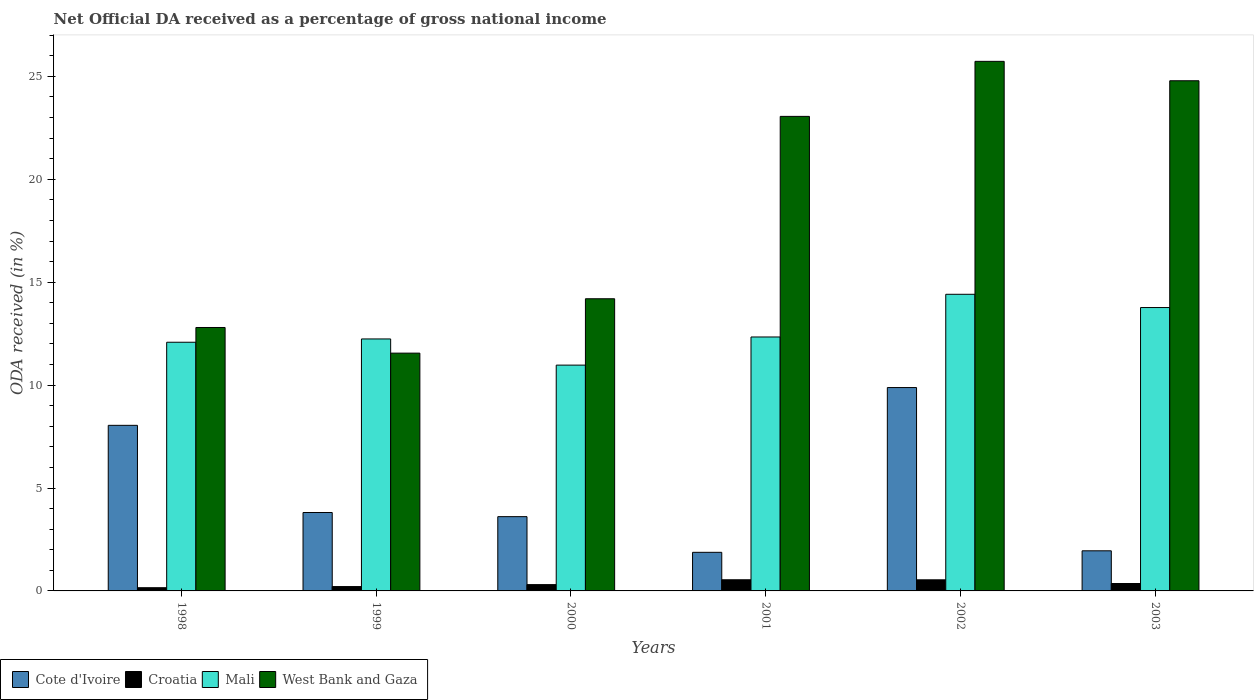How many different coloured bars are there?
Your answer should be compact. 4. How many groups of bars are there?
Provide a succinct answer. 6. Are the number of bars per tick equal to the number of legend labels?
Your response must be concise. Yes. What is the label of the 3rd group of bars from the left?
Your answer should be very brief. 2000. In how many cases, is the number of bars for a given year not equal to the number of legend labels?
Make the answer very short. 0. What is the net official DA received in Cote d'Ivoire in 1998?
Provide a succinct answer. 8.05. Across all years, what is the maximum net official DA received in Cote d'Ivoire?
Offer a very short reply. 9.88. Across all years, what is the minimum net official DA received in Cote d'Ivoire?
Your answer should be very brief. 1.88. In which year was the net official DA received in Mali maximum?
Offer a very short reply. 2002. In which year was the net official DA received in Mali minimum?
Offer a terse response. 2000. What is the total net official DA received in West Bank and Gaza in the graph?
Keep it short and to the point. 112.11. What is the difference between the net official DA received in Croatia in 1999 and that in 2001?
Your answer should be very brief. -0.33. What is the difference between the net official DA received in Cote d'Ivoire in 2000 and the net official DA received in Croatia in 2002?
Provide a succinct answer. 3.07. What is the average net official DA received in Croatia per year?
Ensure brevity in your answer.  0.35. In the year 1999, what is the difference between the net official DA received in Mali and net official DA received in Croatia?
Your answer should be compact. 12.03. In how many years, is the net official DA received in Cote d'Ivoire greater than 12 %?
Your answer should be very brief. 0. What is the ratio of the net official DA received in West Bank and Gaza in 2000 to that in 2001?
Offer a terse response. 0.62. Is the difference between the net official DA received in Mali in 2002 and 2003 greater than the difference between the net official DA received in Croatia in 2002 and 2003?
Offer a very short reply. Yes. What is the difference between the highest and the second highest net official DA received in West Bank and Gaza?
Your answer should be compact. 0.94. What is the difference between the highest and the lowest net official DA received in Croatia?
Ensure brevity in your answer.  0.39. Is it the case that in every year, the sum of the net official DA received in Cote d'Ivoire and net official DA received in Mali is greater than the sum of net official DA received in Croatia and net official DA received in West Bank and Gaza?
Ensure brevity in your answer.  Yes. What does the 1st bar from the left in 1999 represents?
Your answer should be compact. Cote d'Ivoire. What does the 4th bar from the right in 2002 represents?
Your response must be concise. Cote d'Ivoire. Is it the case that in every year, the sum of the net official DA received in West Bank and Gaza and net official DA received in Cote d'Ivoire is greater than the net official DA received in Mali?
Offer a very short reply. Yes. Are all the bars in the graph horizontal?
Provide a short and direct response. No. Where does the legend appear in the graph?
Offer a very short reply. Bottom left. How are the legend labels stacked?
Your answer should be very brief. Horizontal. What is the title of the graph?
Give a very brief answer. Net Official DA received as a percentage of gross national income. Does "China" appear as one of the legend labels in the graph?
Give a very brief answer. No. What is the label or title of the X-axis?
Your answer should be compact. Years. What is the label or title of the Y-axis?
Give a very brief answer. ODA received (in %). What is the ODA received (in %) of Cote d'Ivoire in 1998?
Ensure brevity in your answer.  8.05. What is the ODA received (in %) of Croatia in 1998?
Give a very brief answer. 0.16. What is the ODA received (in %) in Mali in 1998?
Make the answer very short. 12.08. What is the ODA received (in %) in West Bank and Gaza in 1998?
Keep it short and to the point. 12.8. What is the ODA received (in %) in Cote d'Ivoire in 1999?
Your answer should be very brief. 3.81. What is the ODA received (in %) in Croatia in 1999?
Your response must be concise. 0.21. What is the ODA received (in %) in Mali in 1999?
Offer a terse response. 12.24. What is the ODA received (in %) in West Bank and Gaza in 1999?
Provide a short and direct response. 11.55. What is the ODA received (in %) of Cote d'Ivoire in 2000?
Keep it short and to the point. 3.61. What is the ODA received (in %) in Croatia in 2000?
Provide a succinct answer. 0.31. What is the ODA received (in %) of Mali in 2000?
Keep it short and to the point. 10.97. What is the ODA received (in %) in West Bank and Gaza in 2000?
Offer a terse response. 14.19. What is the ODA received (in %) in Cote d'Ivoire in 2001?
Your answer should be very brief. 1.88. What is the ODA received (in %) in Croatia in 2001?
Keep it short and to the point. 0.54. What is the ODA received (in %) in Mali in 2001?
Make the answer very short. 12.34. What is the ODA received (in %) of West Bank and Gaza in 2001?
Offer a terse response. 23.05. What is the ODA received (in %) in Cote d'Ivoire in 2002?
Make the answer very short. 9.88. What is the ODA received (in %) of Croatia in 2002?
Provide a succinct answer. 0.54. What is the ODA received (in %) in Mali in 2002?
Make the answer very short. 14.41. What is the ODA received (in %) in West Bank and Gaza in 2002?
Your answer should be very brief. 25.73. What is the ODA received (in %) in Cote d'Ivoire in 2003?
Offer a very short reply. 1.95. What is the ODA received (in %) in Croatia in 2003?
Your answer should be very brief. 0.36. What is the ODA received (in %) in Mali in 2003?
Offer a very short reply. 13.77. What is the ODA received (in %) of West Bank and Gaza in 2003?
Offer a very short reply. 24.79. Across all years, what is the maximum ODA received (in %) of Cote d'Ivoire?
Make the answer very short. 9.88. Across all years, what is the maximum ODA received (in %) of Croatia?
Keep it short and to the point. 0.54. Across all years, what is the maximum ODA received (in %) in Mali?
Your answer should be compact. 14.41. Across all years, what is the maximum ODA received (in %) in West Bank and Gaza?
Provide a short and direct response. 25.73. Across all years, what is the minimum ODA received (in %) in Cote d'Ivoire?
Your answer should be compact. 1.88. Across all years, what is the minimum ODA received (in %) of Croatia?
Offer a terse response. 0.16. Across all years, what is the minimum ODA received (in %) in Mali?
Ensure brevity in your answer.  10.97. Across all years, what is the minimum ODA received (in %) of West Bank and Gaza?
Your answer should be compact. 11.55. What is the total ODA received (in %) of Cote d'Ivoire in the graph?
Make the answer very short. 29.17. What is the total ODA received (in %) of Croatia in the graph?
Offer a terse response. 2.11. What is the total ODA received (in %) of Mali in the graph?
Your answer should be compact. 75.81. What is the total ODA received (in %) in West Bank and Gaza in the graph?
Your answer should be very brief. 112.11. What is the difference between the ODA received (in %) in Cote d'Ivoire in 1998 and that in 1999?
Your answer should be compact. 4.24. What is the difference between the ODA received (in %) in Croatia in 1998 and that in 1999?
Your response must be concise. -0.06. What is the difference between the ODA received (in %) of Mali in 1998 and that in 1999?
Your answer should be very brief. -0.16. What is the difference between the ODA received (in %) of West Bank and Gaza in 1998 and that in 1999?
Provide a succinct answer. 1.25. What is the difference between the ODA received (in %) of Cote d'Ivoire in 1998 and that in 2000?
Ensure brevity in your answer.  4.44. What is the difference between the ODA received (in %) of Croatia in 1998 and that in 2000?
Make the answer very short. -0.15. What is the difference between the ODA received (in %) of Mali in 1998 and that in 2000?
Your answer should be compact. 1.11. What is the difference between the ODA received (in %) of West Bank and Gaza in 1998 and that in 2000?
Offer a very short reply. -1.4. What is the difference between the ODA received (in %) of Cote d'Ivoire in 1998 and that in 2001?
Offer a terse response. 6.17. What is the difference between the ODA received (in %) of Croatia in 1998 and that in 2001?
Give a very brief answer. -0.39. What is the difference between the ODA received (in %) in Mali in 1998 and that in 2001?
Provide a succinct answer. -0.26. What is the difference between the ODA received (in %) of West Bank and Gaza in 1998 and that in 2001?
Provide a succinct answer. -10.26. What is the difference between the ODA received (in %) in Cote d'Ivoire in 1998 and that in 2002?
Your answer should be very brief. -1.84. What is the difference between the ODA received (in %) in Croatia in 1998 and that in 2002?
Ensure brevity in your answer.  -0.38. What is the difference between the ODA received (in %) in Mali in 1998 and that in 2002?
Offer a very short reply. -2.33. What is the difference between the ODA received (in %) of West Bank and Gaza in 1998 and that in 2002?
Your answer should be compact. -12.93. What is the difference between the ODA received (in %) in Cote d'Ivoire in 1998 and that in 2003?
Ensure brevity in your answer.  6.1. What is the difference between the ODA received (in %) of Croatia in 1998 and that in 2003?
Your response must be concise. -0.2. What is the difference between the ODA received (in %) of Mali in 1998 and that in 2003?
Offer a terse response. -1.69. What is the difference between the ODA received (in %) of West Bank and Gaza in 1998 and that in 2003?
Make the answer very short. -11.99. What is the difference between the ODA received (in %) in Cote d'Ivoire in 1999 and that in 2000?
Offer a terse response. 0.2. What is the difference between the ODA received (in %) in Croatia in 1999 and that in 2000?
Provide a short and direct response. -0.09. What is the difference between the ODA received (in %) of Mali in 1999 and that in 2000?
Provide a succinct answer. 1.27. What is the difference between the ODA received (in %) in West Bank and Gaza in 1999 and that in 2000?
Give a very brief answer. -2.64. What is the difference between the ODA received (in %) in Cote d'Ivoire in 1999 and that in 2001?
Your answer should be compact. 1.93. What is the difference between the ODA received (in %) of Croatia in 1999 and that in 2001?
Provide a short and direct response. -0.33. What is the difference between the ODA received (in %) of Mali in 1999 and that in 2001?
Provide a succinct answer. -0.1. What is the difference between the ODA received (in %) in West Bank and Gaza in 1999 and that in 2001?
Ensure brevity in your answer.  -11.5. What is the difference between the ODA received (in %) of Cote d'Ivoire in 1999 and that in 2002?
Offer a terse response. -6.07. What is the difference between the ODA received (in %) of Croatia in 1999 and that in 2002?
Your answer should be compact. -0.33. What is the difference between the ODA received (in %) in Mali in 1999 and that in 2002?
Give a very brief answer. -2.17. What is the difference between the ODA received (in %) of West Bank and Gaza in 1999 and that in 2002?
Keep it short and to the point. -14.18. What is the difference between the ODA received (in %) of Cote d'Ivoire in 1999 and that in 2003?
Keep it short and to the point. 1.86. What is the difference between the ODA received (in %) in Croatia in 1999 and that in 2003?
Give a very brief answer. -0.15. What is the difference between the ODA received (in %) of Mali in 1999 and that in 2003?
Provide a short and direct response. -1.53. What is the difference between the ODA received (in %) in West Bank and Gaza in 1999 and that in 2003?
Your answer should be compact. -13.23. What is the difference between the ODA received (in %) in Cote d'Ivoire in 2000 and that in 2001?
Make the answer very short. 1.73. What is the difference between the ODA received (in %) of Croatia in 2000 and that in 2001?
Make the answer very short. -0.23. What is the difference between the ODA received (in %) of Mali in 2000 and that in 2001?
Give a very brief answer. -1.37. What is the difference between the ODA received (in %) of West Bank and Gaza in 2000 and that in 2001?
Offer a very short reply. -8.86. What is the difference between the ODA received (in %) of Cote d'Ivoire in 2000 and that in 2002?
Provide a short and direct response. -6.27. What is the difference between the ODA received (in %) in Croatia in 2000 and that in 2002?
Your answer should be compact. -0.23. What is the difference between the ODA received (in %) of Mali in 2000 and that in 2002?
Offer a terse response. -3.44. What is the difference between the ODA received (in %) in West Bank and Gaza in 2000 and that in 2002?
Provide a succinct answer. -11.53. What is the difference between the ODA received (in %) of Cote d'Ivoire in 2000 and that in 2003?
Make the answer very short. 1.66. What is the difference between the ODA received (in %) of Croatia in 2000 and that in 2003?
Your answer should be very brief. -0.05. What is the difference between the ODA received (in %) in Mali in 2000 and that in 2003?
Offer a very short reply. -2.8. What is the difference between the ODA received (in %) of West Bank and Gaza in 2000 and that in 2003?
Your answer should be very brief. -10.59. What is the difference between the ODA received (in %) in Cote d'Ivoire in 2001 and that in 2002?
Provide a succinct answer. -8. What is the difference between the ODA received (in %) of Croatia in 2001 and that in 2002?
Your response must be concise. 0. What is the difference between the ODA received (in %) in Mali in 2001 and that in 2002?
Your response must be concise. -2.07. What is the difference between the ODA received (in %) of West Bank and Gaza in 2001 and that in 2002?
Offer a very short reply. -2.67. What is the difference between the ODA received (in %) in Cote d'Ivoire in 2001 and that in 2003?
Offer a terse response. -0.07. What is the difference between the ODA received (in %) of Croatia in 2001 and that in 2003?
Your response must be concise. 0.18. What is the difference between the ODA received (in %) in Mali in 2001 and that in 2003?
Keep it short and to the point. -1.43. What is the difference between the ODA received (in %) in West Bank and Gaza in 2001 and that in 2003?
Your answer should be compact. -1.73. What is the difference between the ODA received (in %) in Cote d'Ivoire in 2002 and that in 2003?
Your answer should be very brief. 7.93. What is the difference between the ODA received (in %) in Croatia in 2002 and that in 2003?
Keep it short and to the point. 0.18. What is the difference between the ODA received (in %) of Mali in 2002 and that in 2003?
Offer a terse response. 0.64. What is the difference between the ODA received (in %) of West Bank and Gaza in 2002 and that in 2003?
Your answer should be compact. 0.94. What is the difference between the ODA received (in %) in Cote d'Ivoire in 1998 and the ODA received (in %) in Croatia in 1999?
Keep it short and to the point. 7.83. What is the difference between the ODA received (in %) in Cote d'Ivoire in 1998 and the ODA received (in %) in Mali in 1999?
Provide a succinct answer. -4.2. What is the difference between the ODA received (in %) of Cote d'Ivoire in 1998 and the ODA received (in %) of West Bank and Gaza in 1999?
Your response must be concise. -3.51. What is the difference between the ODA received (in %) of Croatia in 1998 and the ODA received (in %) of Mali in 1999?
Make the answer very short. -12.09. What is the difference between the ODA received (in %) of Croatia in 1998 and the ODA received (in %) of West Bank and Gaza in 1999?
Provide a succinct answer. -11.4. What is the difference between the ODA received (in %) in Mali in 1998 and the ODA received (in %) in West Bank and Gaza in 1999?
Ensure brevity in your answer.  0.53. What is the difference between the ODA received (in %) of Cote d'Ivoire in 1998 and the ODA received (in %) of Croatia in 2000?
Offer a terse response. 7.74. What is the difference between the ODA received (in %) of Cote d'Ivoire in 1998 and the ODA received (in %) of Mali in 2000?
Offer a very short reply. -2.92. What is the difference between the ODA received (in %) in Cote d'Ivoire in 1998 and the ODA received (in %) in West Bank and Gaza in 2000?
Your answer should be compact. -6.15. What is the difference between the ODA received (in %) in Croatia in 1998 and the ODA received (in %) in Mali in 2000?
Make the answer very short. -10.81. What is the difference between the ODA received (in %) in Croatia in 1998 and the ODA received (in %) in West Bank and Gaza in 2000?
Provide a succinct answer. -14.04. What is the difference between the ODA received (in %) in Mali in 1998 and the ODA received (in %) in West Bank and Gaza in 2000?
Keep it short and to the point. -2.11. What is the difference between the ODA received (in %) of Cote d'Ivoire in 1998 and the ODA received (in %) of Croatia in 2001?
Provide a short and direct response. 7.5. What is the difference between the ODA received (in %) in Cote d'Ivoire in 1998 and the ODA received (in %) in Mali in 2001?
Your response must be concise. -4.29. What is the difference between the ODA received (in %) in Cote d'Ivoire in 1998 and the ODA received (in %) in West Bank and Gaza in 2001?
Your answer should be compact. -15.01. What is the difference between the ODA received (in %) in Croatia in 1998 and the ODA received (in %) in Mali in 2001?
Your answer should be very brief. -12.18. What is the difference between the ODA received (in %) in Croatia in 1998 and the ODA received (in %) in West Bank and Gaza in 2001?
Your response must be concise. -22.9. What is the difference between the ODA received (in %) of Mali in 1998 and the ODA received (in %) of West Bank and Gaza in 2001?
Make the answer very short. -10.97. What is the difference between the ODA received (in %) of Cote d'Ivoire in 1998 and the ODA received (in %) of Croatia in 2002?
Your answer should be compact. 7.51. What is the difference between the ODA received (in %) in Cote d'Ivoire in 1998 and the ODA received (in %) in Mali in 2002?
Your response must be concise. -6.37. What is the difference between the ODA received (in %) in Cote d'Ivoire in 1998 and the ODA received (in %) in West Bank and Gaza in 2002?
Provide a succinct answer. -17.68. What is the difference between the ODA received (in %) in Croatia in 1998 and the ODA received (in %) in Mali in 2002?
Your response must be concise. -14.26. What is the difference between the ODA received (in %) of Croatia in 1998 and the ODA received (in %) of West Bank and Gaza in 2002?
Give a very brief answer. -25.57. What is the difference between the ODA received (in %) in Mali in 1998 and the ODA received (in %) in West Bank and Gaza in 2002?
Keep it short and to the point. -13.65. What is the difference between the ODA received (in %) in Cote d'Ivoire in 1998 and the ODA received (in %) in Croatia in 2003?
Your answer should be compact. 7.69. What is the difference between the ODA received (in %) in Cote d'Ivoire in 1998 and the ODA received (in %) in Mali in 2003?
Your answer should be very brief. -5.72. What is the difference between the ODA received (in %) of Cote d'Ivoire in 1998 and the ODA received (in %) of West Bank and Gaza in 2003?
Keep it short and to the point. -16.74. What is the difference between the ODA received (in %) of Croatia in 1998 and the ODA received (in %) of Mali in 2003?
Your answer should be very brief. -13.61. What is the difference between the ODA received (in %) of Croatia in 1998 and the ODA received (in %) of West Bank and Gaza in 2003?
Ensure brevity in your answer.  -24.63. What is the difference between the ODA received (in %) of Mali in 1998 and the ODA received (in %) of West Bank and Gaza in 2003?
Keep it short and to the point. -12.7. What is the difference between the ODA received (in %) of Cote d'Ivoire in 1999 and the ODA received (in %) of Croatia in 2000?
Offer a very short reply. 3.5. What is the difference between the ODA received (in %) in Cote d'Ivoire in 1999 and the ODA received (in %) in Mali in 2000?
Offer a terse response. -7.16. What is the difference between the ODA received (in %) in Cote d'Ivoire in 1999 and the ODA received (in %) in West Bank and Gaza in 2000?
Give a very brief answer. -10.38. What is the difference between the ODA received (in %) in Croatia in 1999 and the ODA received (in %) in Mali in 2000?
Your answer should be compact. -10.76. What is the difference between the ODA received (in %) of Croatia in 1999 and the ODA received (in %) of West Bank and Gaza in 2000?
Your answer should be very brief. -13.98. What is the difference between the ODA received (in %) in Mali in 1999 and the ODA received (in %) in West Bank and Gaza in 2000?
Your answer should be very brief. -1.95. What is the difference between the ODA received (in %) in Cote d'Ivoire in 1999 and the ODA received (in %) in Croatia in 2001?
Your response must be concise. 3.27. What is the difference between the ODA received (in %) in Cote d'Ivoire in 1999 and the ODA received (in %) in Mali in 2001?
Provide a short and direct response. -8.53. What is the difference between the ODA received (in %) of Cote d'Ivoire in 1999 and the ODA received (in %) of West Bank and Gaza in 2001?
Offer a very short reply. -19.24. What is the difference between the ODA received (in %) in Croatia in 1999 and the ODA received (in %) in Mali in 2001?
Keep it short and to the point. -12.13. What is the difference between the ODA received (in %) of Croatia in 1999 and the ODA received (in %) of West Bank and Gaza in 2001?
Ensure brevity in your answer.  -22.84. What is the difference between the ODA received (in %) of Mali in 1999 and the ODA received (in %) of West Bank and Gaza in 2001?
Your answer should be compact. -10.81. What is the difference between the ODA received (in %) in Cote d'Ivoire in 1999 and the ODA received (in %) in Croatia in 2002?
Make the answer very short. 3.27. What is the difference between the ODA received (in %) in Cote d'Ivoire in 1999 and the ODA received (in %) in Mali in 2002?
Keep it short and to the point. -10.6. What is the difference between the ODA received (in %) of Cote d'Ivoire in 1999 and the ODA received (in %) of West Bank and Gaza in 2002?
Your answer should be compact. -21.92. What is the difference between the ODA received (in %) of Croatia in 1999 and the ODA received (in %) of Mali in 2002?
Offer a terse response. -14.2. What is the difference between the ODA received (in %) in Croatia in 1999 and the ODA received (in %) in West Bank and Gaza in 2002?
Give a very brief answer. -25.52. What is the difference between the ODA received (in %) in Mali in 1999 and the ODA received (in %) in West Bank and Gaza in 2002?
Keep it short and to the point. -13.49. What is the difference between the ODA received (in %) in Cote d'Ivoire in 1999 and the ODA received (in %) in Croatia in 2003?
Your answer should be compact. 3.45. What is the difference between the ODA received (in %) in Cote d'Ivoire in 1999 and the ODA received (in %) in Mali in 2003?
Make the answer very short. -9.96. What is the difference between the ODA received (in %) in Cote d'Ivoire in 1999 and the ODA received (in %) in West Bank and Gaza in 2003?
Keep it short and to the point. -20.98. What is the difference between the ODA received (in %) in Croatia in 1999 and the ODA received (in %) in Mali in 2003?
Your answer should be compact. -13.56. What is the difference between the ODA received (in %) of Croatia in 1999 and the ODA received (in %) of West Bank and Gaza in 2003?
Keep it short and to the point. -24.57. What is the difference between the ODA received (in %) of Mali in 1999 and the ODA received (in %) of West Bank and Gaza in 2003?
Your response must be concise. -12.54. What is the difference between the ODA received (in %) of Cote d'Ivoire in 2000 and the ODA received (in %) of Croatia in 2001?
Provide a short and direct response. 3.07. What is the difference between the ODA received (in %) of Cote d'Ivoire in 2000 and the ODA received (in %) of Mali in 2001?
Offer a terse response. -8.73. What is the difference between the ODA received (in %) of Cote d'Ivoire in 2000 and the ODA received (in %) of West Bank and Gaza in 2001?
Provide a short and direct response. -19.45. What is the difference between the ODA received (in %) in Croatia in 2000 and the ODA received (in %) in Mali in 2001?
Your answer should be very brief. -12.03. What is the difference between the ODA received (in %) in Croatia in 2000 and the ODA received (in %) in West Bank and Gaza in 2001?
Give a very brief answer. -22.75. What is the difference between the ODA received (in %) of Mali in 2000 and the ODA received (in %) of West Bank and Gaza in 2001?
Make the answer very short. -12.08. What is the difference between the ODA received (in %) in Cote d'Ivoire in 2000 and the ODA received (in %) in Croatia in 2002?
Your answer should be very brief. 3.07. What is the difference between the ODA received (in %) of Cote d'Ivoire in 2000 and the ODA received (in %) of Mali in 2002?
Give a very brief answer. -10.8. What is the difference between the ODA received (in %) in Cote d'Ivoire in 2000 and the ODA received (in %) in West Bank and Gaza in 2002?
Your answer should be compact. -22.12. What is the difference between the ODA received (in %) in Croatia in 2000 and the ODA received (in %) in Mali in 2002?
Offer a terse response. -14.1. What is the difference between the ODA received (in %) of Croatia in 2000 and the ODA received (in %) of West Bank and Gaza in 2002?
Make the answer very short. -25.42. What is the difference between the ODA received (in %) in Mali in 2000 and the ODA received (in %) in West Bank and Gaza in 2002?
Give a very brief answer. -14.76. What is the difference between the ODA received (in %) of Cote d'Ivoire in 2000 and the ODA received (in %) of Croatia in 2003?
Your response must be concise. 3.25. What is the difference between the ODA received (in %) in Cote d'Ivoire in 2000 and the ODA received (in %) in Mali in 2003?
Offer a terse response. -10.16. What is the difference between the ODA received (in %) in Cote d'Ivoire in 2000 and the ODA received (in %) in West Bank and Gaza in 2003?
Offer a very short reply. -21.18. What is the difference between the ODA received (in %) of Croatia in 2000 and the ODA received (in %) of Mali in 2003?
Keep it short and to the point. -13.46. What is the difference between the ODA received (in %) in Croatia in 2000 and the ODA received (in %) in West Bank and Gaza in 2003?
Offer a terse response. -24.48. What is the difference between the ODA received (in %) in Mali in 2000 and the ODA received (in %) in West Bank and Gaza in 2003?
Offer a very short reply. -13.82. What is the difference between the ODA received (in %) in Cote d'Ivoire in 2001 and the ODA received (in %) in Croatia in 2002?
Your response must be concise. 1.34. What is the difference between the ODA received (in %) in Cote d'Ivoire in 2001 and the ODA received (in %) in Mali in 2002?
Ensure brevity in your answer.  -12.54. What is the difference between the ODA received (in %) in Cote d'Ivoire in 2001 and the ODA received (in %) in West Bank and Gaza in 2002?
Make the answer very short. -23.85. What is the difference between the ODA received (in %) in Croatia in 2001 and the ODA received (in %) in Mali in 2002?
Make the answer very short. -13.87. What is the difference between the ODA received (in %) of Croatia in 2001 and the ODA received (in %) of West Bank and Gaza in 2002?
Provide a succinct answer. -25.19. What is the difference between the ODA received (in %) of Mali in 2001 and the ODA received (in %) of West Bank and Gaza in 2002?
Ensure brevity in your answer.  -13.39. What is the difference between the ODA received (in %) of Cote d'Ivoire in 2001 and the ODA received (in %) of Croatia in 2003?
Your answer should be very brief. 1.52. What is the difference between the ODA received (in %) of Cote d'Ivoire in 2001 and the ODA received (in %) of Mali in 2003?
Give a very brief answer. -11.89. What is the difference between the ODA received (in %) in Cote d'Ivoire in 2001 and the ODA received (in %) in West Bank and Gaza in 2003?
Provide a short and direct response. -22.91. What is the difference between the ODA received (in %) of Croatia in 2001 and the ODA received (in %) of Mali in 2003?
Your answer should be very brief. -13.23. What is the difference between the ODA received (in %) of Croatia in 2001 and the ODA received (in %) of West Bank and Gaza in 2003?
Provide a short and direct response. -24.24. What is the difference between the ODA received (in %) in Mali in 2001 and the ODA received (in %) in West Bank and Gaza in 2003?
Offer a very short reply. -12.45. What is the difference between the ODA received (in %) in Cote d'Ivoire in 2002 and the ODA received (in %) in Croatia in 2003?
Make the answer very short. 9.52. What is the difference between the ODA received (in %) in Cote d'Ivoire in 2002 and the ODA received (in %) in Mali in 2003?
Provide a succinct answer. -3.89. What is the difference between the ODA received (in %) in Cote d'Ivoire in 2002 and the ODA received (in %) in West Bank and Gaza in 2003?
Keep it short and to the point. -14.91. What is the difference between the ODA received (in %) in Croatia in 2002 and the ODA received (in %) in Mali in 2003?
Keep it short and to the point. -13.23. What is the difference between the ODA received (in %) of Croatia in 2002 and the ODA received (in %) of West Bank and Gaza in 2003?
Offer a terse response. -24.25. What is the difference between the ODA received (in %) in Mali in 2002 and the ODA received (in %) in West Bank and Gaza in 2003?
Ensure brevity in your answer.  -10.37. What is the average ODA received (in %) in Cote d'Ivoire per year?
Provide a short and direct response. 4.86. What is the average ODA received (in %) in Croatia per year?
Keep it short and to the point. 0.35. What is the average ODA received (in %) in Mali per year?
Provide a succinct answer. 12.63. What is the average ODA received (in %) in West Bank and Gaza per year?
Make the answer very short. 18.69. In the year 1998, what is the difference between the ODA received (in %) in Cote d'Ivoire and ODA received (in %) in Croatia?
Provide a short and direct response. 7.89. In the year 1998, what is the difference between the ODA received (in %) of Cote d'Ivoire and ODA received (in %) of Mali?
Provide a succinct answer. -4.04. In the year 1998, what is the difference between the ODA received (in %) of Cote d'Ivoire and ODA received (in %) of West Bank and Gaza?
Your response must be concise. -4.75. In the year 1998, what is the difference between the ODA received (in %) of Croatia and ODA received (in %) of Mali?
Keep it short and to the point. -11.93. In the year 1998, what is the difference between the ODA received (in %) of Croatia and ODA received (in %) of West Bank and Gaza?
Your response must be concise. -12.64. In the year 1998, what is the difference between the ODA received (in %) of Mali and ODA received (in %) of West Bank and Gaza?
Give a very brief answer. -0.72. In the year 1999, what is the difference between the ODA received (in %) of Cote d'Ivoire and ODA received (in %) of Croatia?
Your response must be concise. 3.6. In the year 1999, what is the difference between the ODA received (in %) in Cote d'Ivoire and ODA received (in %) in Mali?
Offer a very short reply. -8.43. In the year 1999, what is the difference between the ODA received (in %) of Cote d'Ivoire and ODA received (in %) of West Bank and Gaza?
Keep it short and to the point. -7.74. In the year 1999, what is the difference between the ODA received (in %) in Croatia and ODA received (in %) in Mali?
Offer a terse response. -12.03. In the year 1999, what is the difference between the ODA received (in %) in Croatia and ODA received (in %) in West Bank and Gaza?
Keep it short and to the point. -11.34. In the year 1999, what is the difference between the ODA received (in %) in Mali and ODA received (in %) in West Bank and Gaza?
Provide a short and direct response. 0.69. In the year 2000, what is the difference between the ODA received (in %) in Cote d'Ivoire and ODA received (in %) in Croatia?
Give a very brief answer. 3.3. In the year 2000, what is the difference between the ODA received (in %) of Cote d'Ivoire and ODA received (in %) of Mali?
Make the answer very short. -7.36. In the year 2000, what is the difference between the ODA received (in %) of Cote d'Ivoire and ODA received (in %) of West Bank and Gaza?
Your answer should be compact. -10.59. In the year 2000, what is the difference between the ODA received (in %) of Croatia and ODA received (in %) of Mali?
Make the answer very short. -10.66. In the year 2000, what is the difference between the ODA received (in %) in Croatia and ODA received (in %) in West Bank and Gaza?
Ensure brevity in your answer.  -13.89. In the year 2000, what is the difference between the ODA received (in %) in Mali and ODA received (in %) in West Bank and Gaza?
Ensure brevity in your answer.  -3.22. In the year 2001, what is the difference between the ODA received (in %) in Cote d'Ivoire and ODA received (in %) in Croatia?
Keep it short and to the point. 1.33. In the year 2001, what is the difference between the ODA received (in %) of Cote d'Ivoire and ODA received (in %) of Mali?
Offer a very short reply. -10.46. In the year 2001, what is the difference between the ODA received (in %) of Cote d'Ivoire and ODA received (in %) of West Bank and Gaza?
Offer a terse response. -21.18. In the year 2001, what is the difference between the ODA received (in %) in Croatia and ODA received (in %) in Mali?
Make the answer very short. -11.8. In the year 2001, what is the difference between the ODA received (in %) of Croatia and ODA received (in %) of West Bank and Gaza?
Offer a very short reply. -22.51. In the year 2001, what is the difference between the ODA received (in %) of Mali and ODA received (in %) of West Bank and Gaza?
Provide a succinct answer. -10.72. In the year 2002, what is the difference between the ODA received (in %) in Cote d'Ivoire and ODA received (in %) in Croatia?
Ensure brevity in your answer.  9.34. In the year 2002, what is the difference between the ODA received (in %) of Cote d'Ivoire and ODA received (in %) of Mali?
Give a very brief answer. -4.53. In the year 2002, what is the difference between the ODA received (in %) of Cote d'Ivoire and ODA received (in %) of West Bank and Gaza?
Provide a succinct answer. -15.85. In the year 2002, what is the difference between the ODA received (in %) of Croatia and ODA received (in %) of Mali?
Keep it short and to the point. -13.87. In the year 2002, what is the difference between the ODA received (in %) of Croatia and ODA received (in %) of West Bank and Gaza?
Provide a short and direct response. -25.19. In the year 2002, what is the difference between the ODA received (in %) in Mali and ODA received (in %) in West Bank and Gaza?
Give a very brief answer. -11.32. In the year 2003, what is the difference between the ODA received (in %) of Cote d'Ivoire and ODA received (in %) of Croatia?
Provide a short and direct response. 1.59. In the year 2003, what is the difference between the ODA received (in %) in Cote d'Ivoire and ODA received (in %) in Mali?
Provide a short and direct response. -11.82. In the year 2003, what is the difference between the ODA received (in %) in Cote d'Ivoire and ODA received (in %) in West Bank and Gaza?
Offer a terse response. -22.84. In the year 2003, what is the difference between the ODA received (in %) in Croatia and ODA received (in %) in Mali?
Ensure brevity in your answer.  -13.41. In the year 2003, what is the difference between the ODA received (in %) in Croatia and ODA received (in %) in West Bank and Gaza?
Offer a very short reply. -24.43. In the year 2003, what is the difference between the ODA received (in %) in Mali and ODA received (in %) in West Bank and Gaza?
Give a very brief answer. -11.02. What is the ratio of the ODA received (in %) of Cote d'Ivoire in 1998 to that in 1999?
Your answer should be compact. 2.11. What is the ratio of the ODA received (in %) in Croatia in 1998 to that in 1999?
Provide a succinct answer. 0.74. What is the ratio of the ODA received (in %) in West Bank and Gaza in 1998 to that in 1999?
Your answer should be very brief. 1.11. What is the ratio of the ODA received (in %) of Cote d'Ivoire in 1998 to that in 2000?
Offer a very short reply. 2.23. What is the ratio of the ODA received (in %) in Croatia in 1998 to that in 2000?
Make the answer very short. 0.51. What is the ratio of the ODA received (in %) of Mali in 1998 to that in 2000?
Your response must be concise. 1.1. What is the ratio of the ODA received (in %) of West Bank and Gaza in 1998 to that in 2000?
Provide a short and direct response. 0.9. What is the ratio of the ODA received (in %) of Cote d'Ivoire in 1998 to that in 2001?
Offer a very short reply. 4.29. What is the ratio of the ODA received (in %) of Croatia in 1998 to that in 2001?
Give a very brief answer. 0.29. What is the ratio of the ODA received (in %) in Mali in 1998 to that in 2001?
Your answer should be very brief. 0.98. What is the ratio of the ODA received (in %) of West Bank and Gaza in 1998 to that in 2001?
Give a very brief answer. 0.56. What is the ratio of the ODA received (in %) of Cote d'Ivoire in 1998 to that in 2002?
Your response must be concise. 0.81. What is the ratio of the ODA received (in %) of Croatia in 1998 to that in 2002?
Ensure brevity in your answer.  0.29. What is the ratio of the ODA received (in %) in Mali in 1998 to that in 2002?
Offer a very short reply. 0.84. What is the ratio of the ODA received (in %) in West Bank and Gaza in 1998 to that in 2002?
Your response must be concise. 0.5. What is the ratio of the ODA received (in %) of Cote d'Ivoire in 1998 to that in 2003?
Your answer should be very brief. 4.13. What is the ratio of the ODA received (in %) in Croatia in 1998 to that in 2003?
Your answer should be very brief. 0.43. What is the ratio of the ODA received (in %) in Mali in 1998 to that in 2003?
Offer a very short reply. 0.88. What is the ratio of the ODA received (in %) in West Bank and Gaza in 1998 to that in 2003?
Your response must be concise. 0.52. What is the ratio of the ODA received (in %) in Cote d'Ivoire in 1999 to that in 2000?
Your answer should be compact. 1.06. What is the ratio of the ODA received (in %) of Croatia in 1999 to that in 2000?
Offer a very short reply. 0.69. What is the ratio of the ODA received (in %) in Mali in 1999 to that in 2000?
Provide a succinct answer. 1.12. What is the ratio of the ODA received (in %) of West Bank and Gaza in 1999 to that in 2000?
Offer a very short reply. 0.81. What is the ratio of the ODA received (in %) of Cote d'Ivoire in 1999 to that in 2001?
Ensure brevity in your answer.  2.03. What is the ratio of the ODA received (in %) of Croatia in 1999 to that in 2001?
Keep it short and to the point. 0.39. What is the ratio of the ODA received (in %) in Mali in 1999 to that in 2001?
Your answer should be very brief. 0.99. What is the ratio of the ODA received (in %) of West Bank and Gaza in 1999 to that in 2001?
Provide a short and direct response. 0.5. What is the ratio of the ODA received (in %) in Cote d'Ivoire in 1999 to that in 2002?
Provide a succinct answer. 0.39. What is the ratio of the ODA received (in %) in Croatia in 1999 to that in 2002?
Provide a succinct answer. 0.39. What is the ratio of the ODA received (in %) in Mali in 1999 to that in 2002?
Offer a very short reply. 0.85. What is the ratio of the ODA received (in %) in West Bank and Gaza in 1999 to that in 2002?
Make the answer very short. 0.45. What is the ratio of the ODA received (in %) in Cote d'Ivoire in 1999 to that in 2003?
Provide a succinct answer. 1.96. What is the ratio of the ODA received (in %) of Croatia in 1999 to that in 2003?
Keep it short and to the point. 0.59. What is the ratio of the ODA received (in %) of Mali in 1999 to that in 2003?
Provide a succinct answer. 0.89. What is the ratio of the ODA received (in %) of West Bank and Gaza in 1999 to that in 2003?
Offer a very short reply. 0.47. What is the ratio of the ODA received (in %) in Cote d'Ivoire in 2000 to that in 2001?
Your answer should be very brief. 1.92. What is the ratio of the ODA received (in %) in Croatia in 2000 to that in 2001?
Offer a terse response. 0.57. What is the ratio of the ODA received (in %) of Mali in 2000 to that in 2001?
Offer a very short reply. 0.89. What is the ratio of the ODA received (in %) in West Bank and Gaza in 2000 to that in 2001?
Your answer should be compact. 0.62. What is the ratio of the ODA received (in %) of Cote d'Ivoire in 2000 to that in 2002?
Offer a terse response. 0.37. What is the ratio of the ODA received (in %) of Croatia in 2000 to that in 2002?
Your answer should be very brief. 0.57. What is the ratio of the ODA received (in %) of Mali in 2000 to that in 2002?
Offer a terse response. 0.76. What is the ratio of the ODA received (in %) in West Bank and Gaza in 2000 to that in 2002?
Offer a very short reply. 0.55. What is the ratio of the ODA received (in %) in Cote d'Ivoire in 2000 to that in 2003?
Offer a very short reply. 1.85. What is the ratio of the ODA received (in %) of Croatia in 2000 to that in 2003?
Provide a short and direct response. 0.85. What is the ratio of the ODA received (in %) in Mali in 2000 to that in 2003?
Your answer should be compact. 0.8. What is the ratio of the ODA received (in %) of West Bank and Gaza in 2000 to that in 2003?
Provide a short and direct response. 0.57. What is the ratio of the ODA received (in %) of Cote d'Ivoire in 2001 to that in 2002?
Keep it short and to the point. 0.19. What is the ratio of the ODA received (in %) in Croatia in 2001 to that in 2002?
Keep it short and to the point. 1. What is the ratio of the ODA received (in %) in Mali in 2001 to that in 2002?
Give a very brief answer. 0.86. What is the ratio of the ODA received (in %) in West Bank and Gaza in 2001 to that in 2002?
Make the answer very short. 0.9. What is the ratio of the ODA received (in %) in Cote d'Ivoire in 2001 to that in 2003?
Offer a terse response. 0.96. What is the ratio of the ODA received (in %) of Croatia in 2001 to that in 2003?
Provide a succinct answer. 1.5. What is the ratio of the ODA received (in %) in Mali in 2001 to that in 2003?
Make the answer very short. 0.9. What is the ratio of the ODA received (in %) of West Bank and Gaza in 2001 to that in 2003?
Make the answer very short. 0.93. What is the ratio of the ODA received (in %) of Cote d'Ivoire in 2002 to that in 2003?
Give a very brief answer. 5.07. What is the ratio of the ODA received (in %) of Croatia in 2002 to that in 2003?
Make the answer very short. 1.5. What is the ratio of the ODA received (in %) in Mali in 2002 to that in 2003?
Offer a terse response. 1.05. What is the ratio of the ODA received (in %) of West Bank and Gaza in 2002 to that in 2003?
Give a very brief answer. 1.04. What is the difference between the highest and the second highest ODA received (in %) of Cote d'Ivoire?
Provide a succinct answer. 1.84. What is the difference between the highest and the second highest ODA received (in %) of Croatia?
Ensure brevity in your answer.  0. What is the difference between the highest and the second highest ODA received (in %) of Mali?
Offer a very short reply. 0.64. What is the difference between the highest and the second highest ODA received (in %) in West Bank and Gaza?
Your response must be concise. 0.94. What is the difference between the highest and the lowest ODA received (in %) of Cote d'Ivoire?
Your answer should be very brief. 8. What is the difference between the highest and the lowest ODA received (in %) of Croatia?
Your answer should be very brief. 0.39. What is the difference between the highest and the lowest ODA received (in %) of Mali?
Provide a succinct answer. 3.44. What is the difference between the highest and the lowest ODA received (in %) in West Bank and Gaza?
Your answer should be compact. 14.18. 